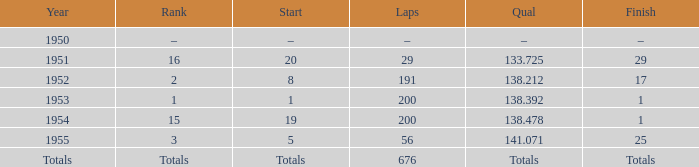What year was the ranking 1? 1953.0. 